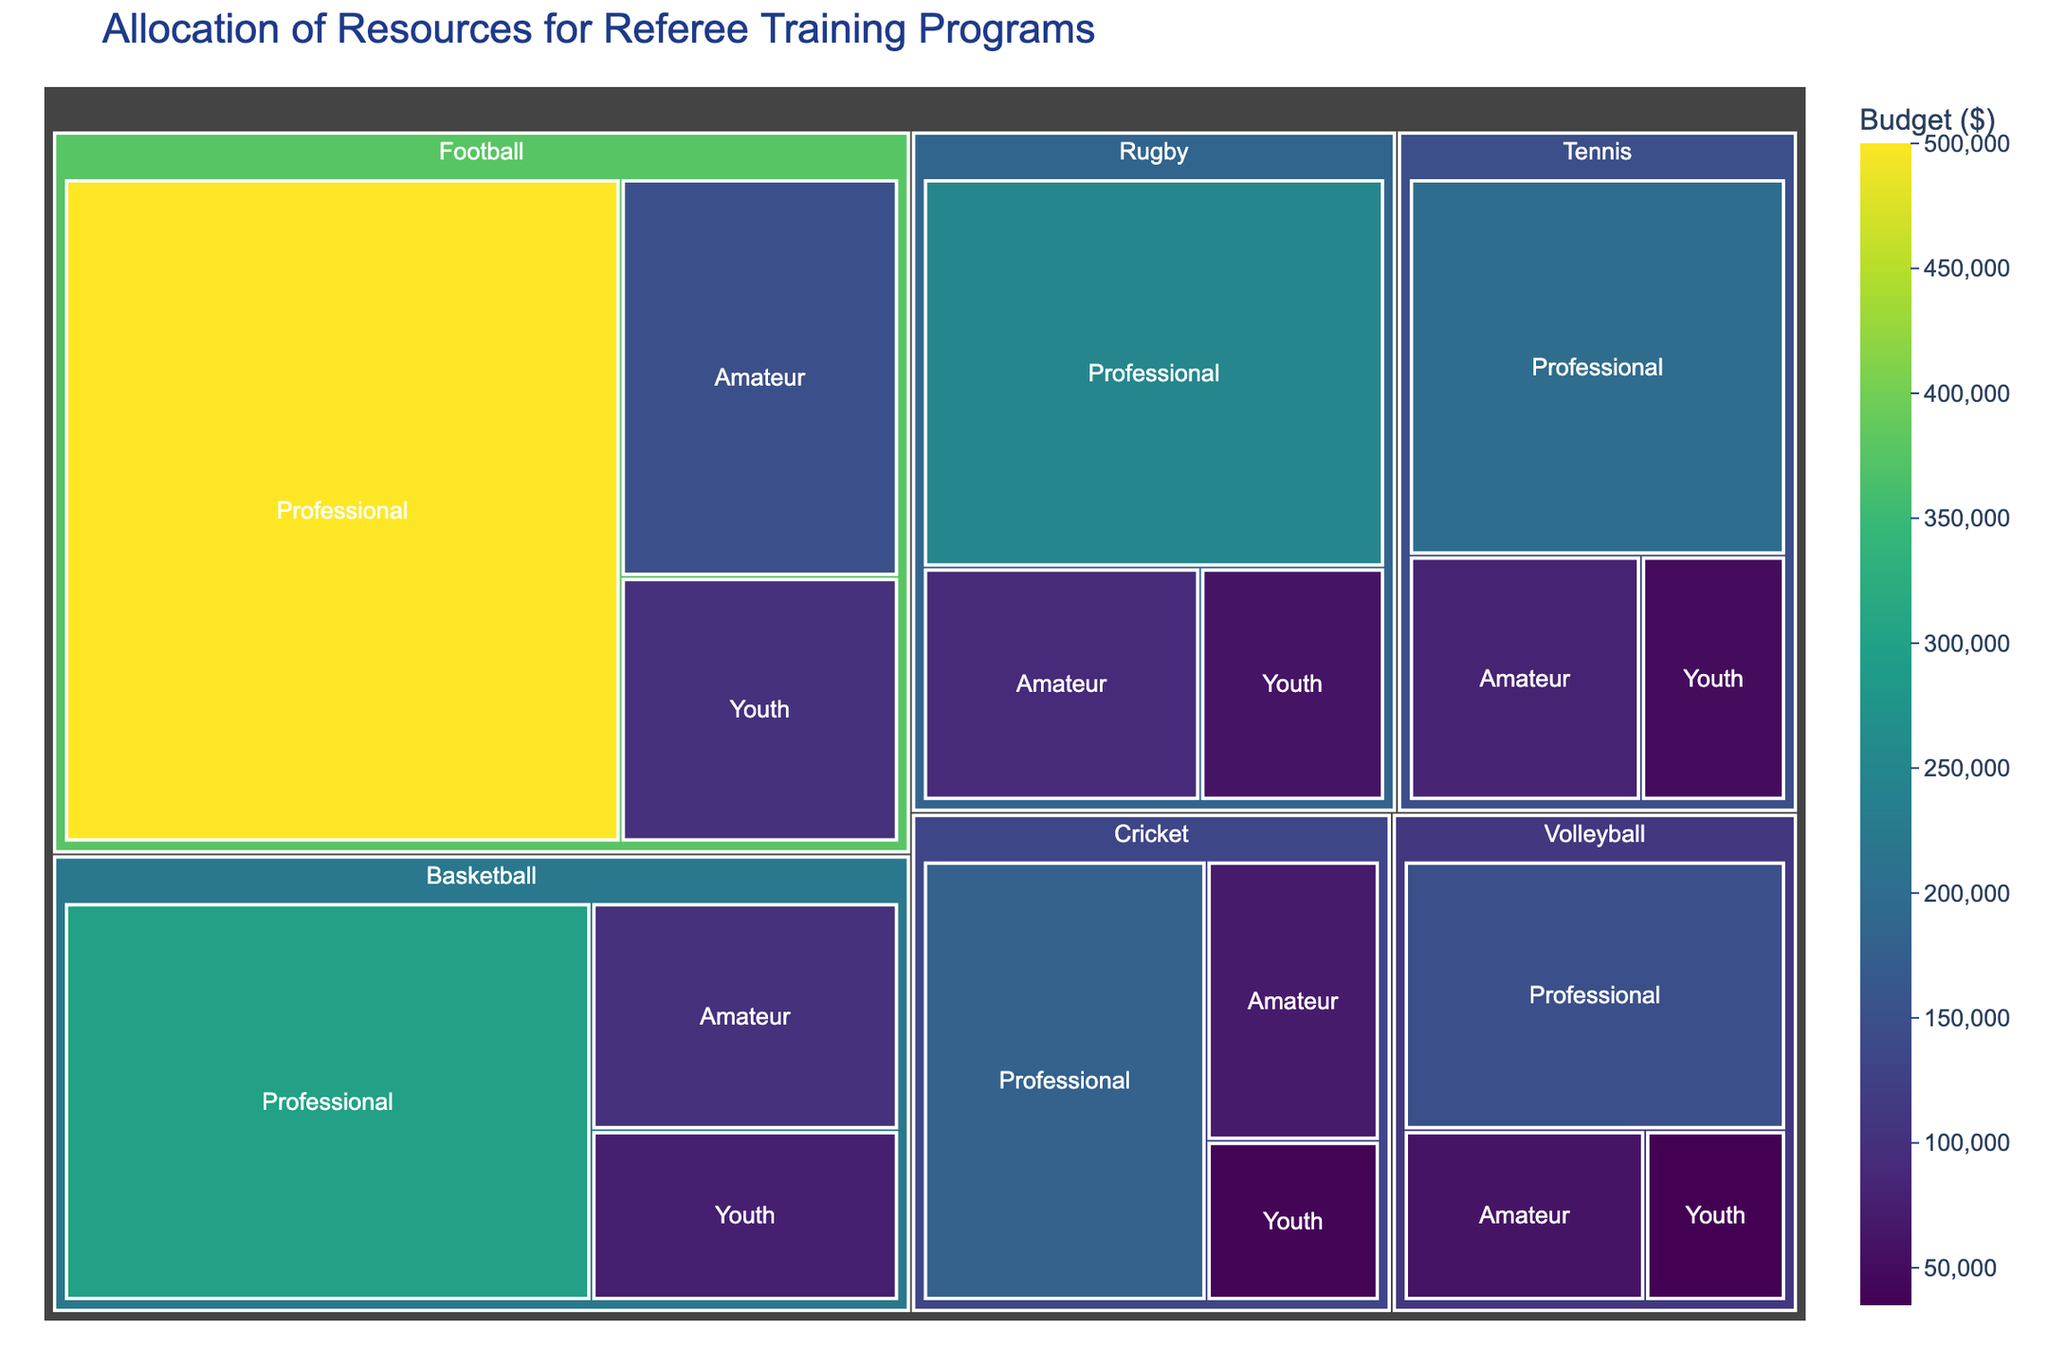what is the total budget allocated for refereeing training in football? The figure's treemap allows us to visually summarize the budget for football at three levels. Summing these values provides the total budget: $500,000 (Professional) + $150,000 (Amateur) + $100,000 (Youth).
Answer: $750,000 which sport has the highest budget allocation for professional level training? By observing the treemap, the professional levels of each sport can be compared to see which has the highest budget. Football's professional training allocation of $500,000 is visibly the highest.
Answer: Football what is the total combined budget for youth training across all sports? We can add up the budget allocations for youth training across all sports from the treemap. ($100,000 for Football) + ($75,000 for Basketball) + ($50,000 for Tennis) + ($60,000 for Rugby) + ($40,000 for Cricket) + ($35,000 for Volleyball) provides the total.
Answer: $360,000 which sport has the lowest budget allocation at the youth level? By comparing the budget allocations for youth level across all columns in the treemap, we see that Volleyball has the lowest at $35,000.
Answer: Volleyball how does the budget for amateur basketball training compare to amateur rugby training? The treemap shows the budgets for amateur levels in both sports. Basketball amateur training has $100,000 and Rugby amateur training has $90,000, so Basketball amateur training has a slightly higher budget.
Answer: Basketball's budget is higher what is the difference in budget allocation between professional and amateur training in rugby? From the data on the treemap, subtract the amateur budget from the professional budget for Rugby: $250,000 (Professional) - $90,000 (Amateur).
Answer: $160,000 what proportion of the total tennis budget is allocated to professional training? First, calculate the total budget for Tennis by summing all levels: $200,000 (Professional) + $80,000 (Amateur) + $50,000 (Youth) = $330,000. Then find the proportion for professional: $200,000 / $330,000 ≈ 0.606, or about 60.6%.
Answer: 60.6% which sport has the highest total budget for all levels combined? Summing up the budgets for all levels within each sport and comparing them reveals that Football has the highest total: $500,000 (Professional) + $150,000 (Amateur) + $100,000 (Youth) totals to $750,000.
Answer: Football what is the percentage difference between the budget allocated for football and basketball at the professional level? Calculate the difference between the budgets: $500,000 (Football) - $300,000 (Basketball) = $200,000. To find the percentage difference, (200,000 / 500,000) * 100% = 40%.
Answer: 40% how does the average budget allocation for the amateur level compare across all sports? Calculate the sum of amateur budgets across all sports: $150,000 (Football) + $100,000 (Basketball) + $80,000 (Tennis) + $90,000 (Rugby) + $70,000 (Cricket) + $60,000 (Volleyball) = $550,000. Divide by the number of sports (6) to get the average: $550,000 / 6 ≈ $91,667.
Answer: $91,667 